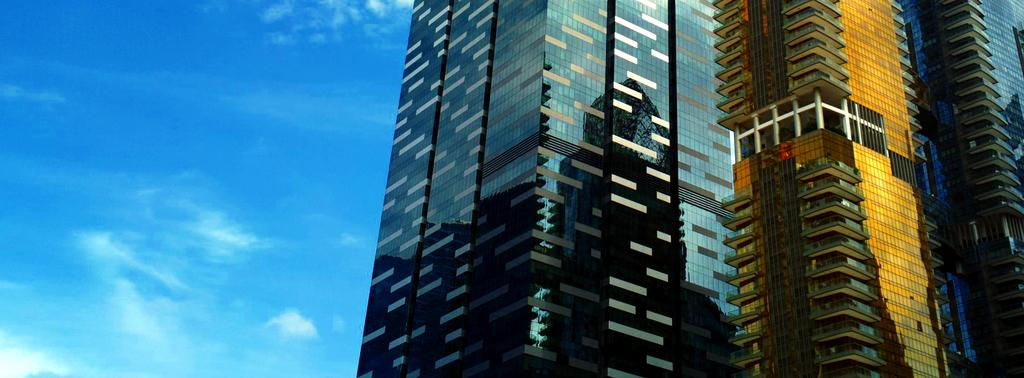What type of structure is the main subject in the image? There is a high-rise building in the image. What type of substance is the high-rise building made of in the image? The fact provided does not mention the substance the high-rise building is made of, so it cannot be determined from the image. How many ladybugs can be seen on the high-rise building in the image? There are no ladybugs present on the high-rise building in the image. 